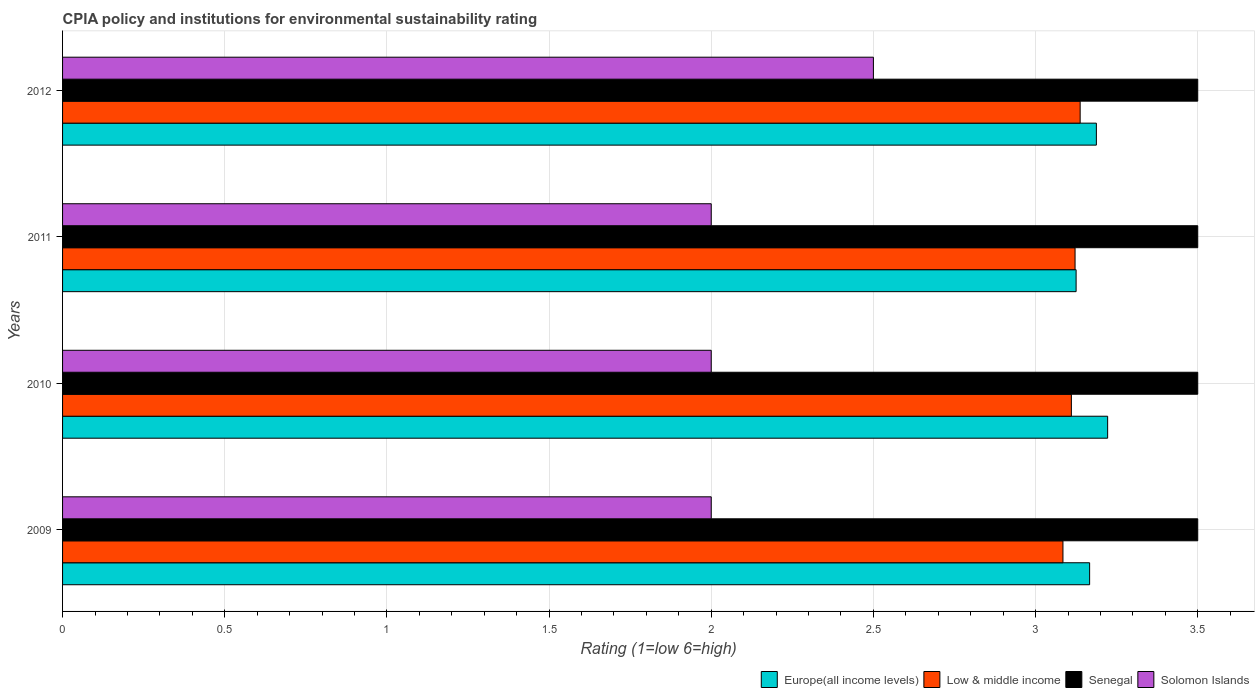Are the number of bars per tick equal to the number of legend labels?
Ensure brevity in your answer.  Yes. Are the number of bars on each tick of the Y-axis equal?
Your answer should be very brief. Yes. What is the label of the 4th group of bars from the top?
Offer a terse response. 2009. In how many cases, is the number of bars for a given year not equal to the number of legend labels?
Your answer should be compact. 0. What is the CPIA rating in Low & middle income in 2009?
Keep it short and to the point. 3.08. Across all years, what is the maximum CPIA rating in Low & middle income?
Offer a very short reply. 3.14. Across all years, what is the minimum CPIA rating in Low & middle income?
Provide a short and direct response. 3.08. What is the total CPIA rating in Low & middle income in the graph?
Provide a succinct answer. 12.45. What is the difference between the CPIA rating in Europe(all income levels) in 2009 and that in 2012?
Offer a terse response. -0.02. What is the difference between the CPIA rating in Senegal in 2011 and the CPIA rating in Low & middle income in 2012?
Make the answer very short. 0.36. What is the average CPIA rating in Europe(all income levels) per year?
Provide a succinct answer. 3.18. In how many years, is the CPIA rating in Senegal greater than 1.1 ?
Provide a succinct answer. 4. Is the CPIA rating in Europe(all income levels) in 2010 less than that in 2011?
Provide a short and direct response. No. What is the difference between the highest and the second highest CPIA rating in Europe(all income levels)?
Make the answer very short. 0.03. What is the difference between the highest and the lowest CPIA rating in Low & middle income?
Keep it short and to the point. 0.05. What does the 4th bar from the top in 2011 represents?
Your answer should be compact. Europe(all income levels). What does the 2nd bar from the bottom in 2011 represents?
Offer a terse response. Low & middle income. Are all the bars in the graph horizontal?
Provide a short and direct response. Yes. How many years are there in the graph?
Make the answer very short. 4. What is the difference between two consecutive major ticks on the X-axis?
Ensure brevity in your answer.  0.5. Are the values on the major ticks of X-axis written in scientific E-notation?
Your answer should be compact. No. Does the graph contain any zero values?
Provide a short and direct response. No. Does the graph contain grids?
Your answer should be compact. Yes. How are the legend labels stacked?
Offer a terse response. Horizontal. What is the title of the graph?
Make the answer very short. CPIA policy and institutions for environmental sustainability rating. What is the Rating (1=low 6=high) of Europe(all income levels) in 2009?
Make the answer very short. 3.17. What is the Rating (1=low 6=high) in Low & middle income in 2009?
Provide a succinct answer. 3.08. What is the Rating (1=low 6=high) in Senegal in 2009?
Keep it short and to the point. 3.5. What is the Rating (1=low 6=high) in Solomon Islands in 2009?
Your answer should be very brief. 2. What is the Rating (1=low 6=high) in Europe(all income levels) in 2010?
Offer a very short reply. 3.22. What is the Rating (1=low 6=high) of Low & middle income in 2010?
Ensure brevity in your answer.  3.11. What is the Rating (1=low 6=high) of Europe(all income levels) in 2011?
Offer a terse response. 3.12. What is the Rating (1=low 6=high) in Low & middle income in 2011?
Your answer should be very brief. 3.12. What is the Rating (1=low 6=high) of Senegal in 2011?
Your answer should be compact. 3.5. What is the Rating (1=low 6=high) in Solomon Islands in 2011?
Give a very brief answer. 2. What is the Rating (1=low 6=high) of Europe(all income levels) in 2012?
Provide a succinct answer. 3.19. What is the Rating (1=low 6=high) in Low & middle income in 2012?
Your response must be concise. 3.14. What is the Rating (1=low 6=high) of Solomon Islands in 2012?
Provide a succinct answer. 2.5. Across all years, what is the maximum Rating (1=low 6=high) in Europe(all income levels)?
Offer a very short reply. 3.22. Across all years, what is the maximum Rating (1=low 6=high) of Low & middle income?
Give a very brief answer. 3.14. Across all years, what is the maximum Rating (1=low 6=high) of Senegal?
Your response must be concise. 3.5. Across all years, what is the maximum Rating (1=low 6=high) in Solomon Islands?
Offer a terse response. 2.5. Across all years, what is the minimum Rating (1=low 6=high) in Europe(all income levels)?
Make the answer very short. 3.12. Across all years, what is the minimum Rating (1=low 6=high) of Low & middle income?
Give a very brief answer. 3.08. Across all years, what is the minimum Rating (1=low 6=high) of Solomon Islands?
Keep it short and to the point. 2. What is the total Rating (1=low 6=high) of Europe(all income levels) in the graph?
Provide a succinct answer. 12.7. What is the total Rating (1=low 6=high) of Low & middle income in the graph?
Make the answer very short. 12.45. What is the total Rating (1=low 6=high) of Solomon Islands in the graph?
Provide a short and direct response. 8.5. What is the difference between the Rating (1=low 6=high) in Europe(all income levels) in 2009 and that in 2010?
Provide a succinct answer. -0.06. What is the difference between the Rating (1=low 6=high) in Low & middle income in 2009 and that in 2010?
Your answer should be very brief. -0.03. What is the difference between the Rating (1=low 6=high) of Senegal in 2009 and that in 2010?
Keep it short and to the point. 0. What is the difference between the Rating (1=low 6=high) of Europe(all income levels) in 2009 and that in 2011?
Offer a terse response. 0.04. What is the difference between the Rating (1=low 6=high) of Low & middle income in 2009 and that in 2011?
Provide a succinct answer. -0.04. What is the difference between the Rating (1=low 6=high) of Europe(all income levels) in 2009 and that in 2012?
Keep it short and to the point. -0.02. What is the difference between the Rating (1=low 6=high) in Low & middle income in 2009 and that in 2012?
Keep it short and to the point. -0.05. What is the difference between the Rating (1=low 6=high) of Senegal in 2009 and that in 2012?
Provide a short and direct response. 0. What is the difference between the Rating (1=low 6=high) of Solomon Islands in 2009 and that in 2012?
Offer a terse response. -0.5. What is the difference between the Rating (1=low 6=high) in Europe(all income levels) in 2010 and that in 2011?
Give a very brief answer. 0.1. What is the difference between the Rating (1=low 6=high) of Low & middle income in 2010 and that in 2011?
Your answer should be compact. -0.01. What is the difference between the Rating (1=low 6=high) in Europe(all income levels) in 2010 and that in 2012?
Offer a very short reply. 0.03. What is the difference between the Rating (1=low 6=high) of Low & middle income in 2010 and that in 2012?
Offer a terse response. -0.03. What is the difference between the Rating (1=low 6=high) in Senegal in 2010 and that in 2012?
Provide a succinct answer. 0. What is the difference between the Rating (1=low 6=high) of Europe(all income levels) in 2011 and that in 2012?
Your response must be concise. -0.06. What is the difference between the Rating (1=low 6=high) in Low & middle income in 2011 and that in 2012?
Offer a very short reply. -0.02. What is the difference between the Rating (1=low 6=high) of Solomon Islands in 2011 and that in 2012?
Make the answer very short. -0.5. What is the difference between the Rating (1=low 6=high) in Europe(all income levels) in 2009 and the Rating (1=low 6=high) in Low & middle income in 2010?
Keep it short and to the point. 0.06. What is the difference between the Rating (1=low 6=high) in Europe(all income levels) in 2009 and the Rating (1=low 6=high) in Senegal in 2010?
Your answer should be very brief. -0.33. What is the difference between the Rating (1=low 6=high) in Low & middle income in 2009 and the Rating (1=low 6=high) in Senegal in 2010?
Your response must be concise. -0.42. What is the difference between the Rating (1=low 6=high) in Low & middle income in 2009 and the Rating (1=low 6=high) in Solomon Islands in 2010?
Offer a terse response. 1.08. What is the difference between the Rating (1=low 6=high) in Senegal in 2009 and the Rating (1=low 6=high) in Solomon Islands in 2010?
Provide a short and direct response. 1.5. What is the difference between the Rating (1=low 6=high) in Europe(all income levels) in 2009 and the Rating (1=low 6=high) in Low & middle income in 2011?
Your answer should be compact. 0.04. What is the difference between the Rating (1=low 6=high) in Europe(all income levels) in 2009 and the Rating (1=low 6=high) in Solomon Islands in 2011?
Your response must be concise. 1.17. What is the difference between the Rating (1=low 6=high) of Low & middle income in 2009 and the Rating (1=low 6=high) of Senegal in 2011?
Make the answer very short. -0.42. What is the difference between the Rating (1=low 6=high) of Low & middle income in 2009 and the Rating (1=low 6=high) of Solomon Islands in 2011?
Your response must be concise. 1.08. What is the difference between the Rating (1=low 6=high) of Europe(all income levels) in 2009 and the Rating (1=low 6=high) of Low & middle income in 2012?
Keep it short and to the point. 0.03. What is the difference between the Rating (1=low 6=high) in Low & middle income in 2009 and the Rating (1=low 6=high) in Senegal in 2012?
Your answer should be very brief. -0.42. What is the difference between the Rating (1=low 6=high) of Low & middle income in 2009 and the Rating (1=low 6=high) of Solomon Islands in 2012?
Provide a short and direct response. 0.58. What is the difference between the Rating (1=low 6=high) in Senegal in 2009 and the Rating (1=low 6=high) in Solomon Islands in 2012?
Make the answer very short. 1. What is the difference between the Rating (1=low 6=high) in Europe(all income levels) in 2010 and the Rating (1=low 6=high) in Low & middle income in 2011?
Ensure brevity in your answer.  0.1. What is the difference between the Rating (1=low 6=high) of Europe(all income levels) in 2010 and the Rating (1=low 6=high) of Senegal in 2011?
Your answer should be compact. -0.28. What is the difference between the Rating (1=low 6=high) of Europe(all income levels) in 2010 and the Rating (1=low 6=high) of Solomon Islands in 2011?
Give a very brief answer. 1.22. What is the difference between the Rating (1=low 6=high) in Low & middle income in 2010 and the Rating (1=low 6=high) in Senegal in 2011?
Offer a terse response. -0.39. What is the difference between the Rating (1=low 6=high) in Low & middle income in 2010 and the Rating (1=low 6=high) in Solomon Islands in 2011?
Ensure brevity in your answer.  1.11. What is the difference between the Rating (1=low 6=high) in Europe(all income levels) in 2010 and the Rating (1=low 6=high) in Low & middle income in 2012?
Provide a short and direct response. 0.08. What is the difference between the Rating (1=low 6=high) of Europe(all income levels) in 2010 and the Rating (1=low 6=high) of Senegal in 2012?
Your answer should be very brief. -0.28. What is the difference between the Rating (1=low 6=high) in Europe(all income levels) in 2010 and the Rating (1=low 6=high) in Solomon Islands in 2012?
Your answer should be compact. 0.72. What is the difference between the Rating (1=low 6=high) of Low & middle income in 2010 and the Rating (1=low 6=high) of Senegal in 2012?
Provide a short and direct response. -0.39. What is the difference between the Rating (1=low 6=high) in Low & middle income in 2010 and the Rating (1=low 6=high) in Solomon Islands in 2012?
Keep it short and to the point. 0.61. What is the difference between the Rating (1=low 6=high) in Senegal in 2010 and the Rating (1=low 6=high) in Solomon Islands in 2012?
Ensure brevity in your answer.  1. What is the difference between the Rating (1=low 6=high) in Europe(all income levels) in 2011 and the Rating (1=low 6=high) in Low & middle income in 2012?
Provide a succinct answer. -0.01. What is the difference between the Rating (1=low 6=high) in Europe(all income levels) in 2011 and the Rating (1=low 6=high) in Senegal in 2012?
Your response must be concise. -0.38. What is the difference between the Rating (1=low 6=high) of Europe(all income levels) in 2011 and the Rating (1=low 6=high) of Solomon Islands in 2012?
Your answer should be very brief. 0.62. What is the difference between the Rating (1=low 6=high) of Low & middle income in 2011 and the Rating (1=low 6=high) of Senegal in 2012?
Your answer should be compact. -0.38. What is the difference between the Rating (1=low 6=high) in Low & middle income in 2011 and the Rating (1=low 6=high) in Solomon Islands in 2012?
Offer a very short reply. 0.62. What is the average Rating (1=low 6=high) in Europe(all income levels) per year?
Offer a very short reply. 3.18. What is the average Rating (1=low 6=high) in Low & middle income per year?
Give a very brief answer. 3.11. What is the average Rating (1=low 6=high) of Senegal per year?
Ensure brevity in your answer.  3.5. What is the average Rating (1=low 6=high) of Solomon Islands per year?
Make the answer very short. 2.12. In the year 2009, what is the difference between the Rating (1=low 6=high) of Europe(all income levels) and Rating (1=low 6=high) of Low & middle income?
Offer a terse response. 0.08. In the year 2009, what is the difference between the Rating (1=low 6=high) of Low & middle income and Rating (1=low 6=high) of Senegal?
Provide a succinct answer. -0.42. In the year 2009, what is the difference between the Rating (1=low 6=high) of Low & middle income and Rating (1=low 6=high) of Solomon Islands?
Your answer should be compact. 1.08. In the year 2010, what is the difference between the Rating (1=low 6=high) in Europe(all income levels) and Rating (1=low 6=high) in Low & middle income?
Offer a terse response. 0.11. In the year 2010, what is the difference between the Rating (1=low 6=high) of Europe(all income levels) and Rating (1=low 6=high) of Senegal?
Provide a succinct answer. -0.28. In the year 2010, what is the difference between the Rating (1=low 6=high) in Europe(all income levels) and Rating (1=low 6=high) in Solomon Islands?
Make the answer very short. 1.22. In the year 2010, what is the difference between the Rating (1=low 6=high) in Low & middle income and Rating (1=low 6=high) in Senegal?
Your answer should be compact. -0.39. In the year 2010, what is the difference between the Rating (1=low 6=high) in Low & middle income and Rating (1=low 6=high) in Solomon Islands?
Your answer should be very brief. 1.11. In the year 2010, what is the difference between the Rating (1=low 6=high) of Senegal and Rating (1=low 6=high) of Solomon Islands?
Offer a very short reply. 1.5. In the year 2011, what is the difference between the Rating (1=low 6=high) in Europe(all income levels) and Rating (1=low 6=high) in Low & middle income?
Make the answer very short. 0. In the year 2011, what is the difference between the Rating (1=low 6=high) of Europe(all income levels) and Rating (1=low 6=high) of Senegal?
Your answer should be compact. -0.38. In the year 2011, what is the difference between the Rating (1=low 6=high) of Europe(all income levels) and Rating (1=low 6=high) of Solomon Islands?
Offer a terse response. 1.12. In the year 2011, what is the difference between the Rating (1=low 6=high) of Low & middle income and Rating (1=low 6=high) of Senegal?
Your answer should be very brief. -0.38. In the year 2011, what is the difference between the Rating (1=low 6=high) of Low & middle income and Rating (1=low 6=high) of Solomon Islands?
Your response must be concise. 1.12. In the year 2012, what is the difference between the Rating (1=low 6=high) in Europe(all income levels) and Rating (1=low 6=high) in Senegal?
Offer a very short reply. -0.31. In the year 2012, what is the difference between the Rating (1=low 6=high) in Europe(all income levels) and Rating (1=low 6=high) in Solomon Islands?
Provide a short and direct response. 0.69. In the year 2012, what is the difference between the Rating (1=low 6=high) of Low & middle income and Rating (1=low 6=high) of Senegal?
Offer a terse response. -0.36. In the year 2012, what is the difference between the Rating (1=low 6=high) of Low & middle income and Rating (1=low 6=high) of Solomon Islands?
Your answer should be compact. 0.64. In the year 2012, what is the difference between the Rating (1=low 6=high) in Senegal and Rating (1=low 6=high) in Solomon Islands?
Offer a terse response. 1. What is the ratio of the Rating (1=low 6=high) in Europe(all income levels) in 2009 to that in 2010?
Give a very brief answer. 0.98. What is the ratio of the Rating (1=low 6=high) in Solomon Islands in 2009 to that in 2010?
Provide a succinct answer. 1. What is the ratio of the Rating (1=low 6=high) in Europe(all income levels) in 2009 to that in 2011?
Offer a terse response. 1.01. What is the ratio of the Rating (1=low 6=high) of Senegal in 2009 to that in 2011?
Provide a short and direct response. 1. What is the ratio of the Rating (1=low 6=high) of Low & middle income in 2009 to that in 2012?
Your answer should be very brief. 0.98. What is the ratio of the Rating (1=low 6=high) of Solomon Islands in 2009 to that in 2012?
Make the answer very short. 0.8. What is the ratio of the Rating (1=low 6=high) of Europe(all income levels) in 2010 to that in 2011?
Offer a terse response. 1.03. What is the ratio of the Rating (1=low 6=high) of Senegal in 2010 to that in 2011?
Ensure brevity in your answer.  1. What is the ratio of the Rating (1=low 6=high) of Solomon Islands in 2010 to that in 2011?
Provide a short and direct response. 1. What is the ratio of the Rating (1=low 6=high) of Europe(all income levels) in 2010 to that in 2012?
Your answer should be compact. 1.01. What is the ratio of the Rating (1=low 6=high) in Senegal in 2010 to that in 2012?
Make the answer very short. 1. What is the ratio of the Rating (1=low 6=high) in Solomon Islands in 2010 to that in 2012?
Offer a terse response. 0.8. What is the ratio of the Rating (1=low 6=high) in Europe(all income levels) in 2011 to that in 2012?
Offer a very short reply. 0.98. What is the ratio of the Rating (1=low 6=high) in Low & middle income in 2011 to that in 2012?
Offer a very short reply. 0.99. What is the ratio of the Rating (1=low 6=high) in Senegal in 2011 to that in 2012?
Give a very brief answer. 1. What is the ratio of the Rating (1=low 6=high) of Solomon Islands in 2011 to that in 2012?
Your response must be concise. 0.8. What is the difference between the highest and the second highest Rating (1=low 6=high) of Europe(all income levels)?
Provide a short and direct response. 0.03. What is the difference between the highest and the second highest Rating (1=low 6=high) of Low & middle income?
Ensure brevity in your answer.  0.02. What is the difference between the highest and the second highest Rating (1=low 6=high) in Senegal?
Offer a terse response. 0. What is the difference between the highest and the second highest Rating (1=low 6=high) in Solomon Islands?
Your response must be concise. 0.5. What is the difference between the highest and the lowest Rating (1=low 6=high) in Europe(all income levels)?
Provide a short and direct response. 0.1. What is the difference between the highest and the lowest Rating (1=low 6=high) of Low & middle income?
Your answer should be very brief. 0.05. What is the difference between the highest and the lowest Rating (1=low 6=high) of Senegal?
Ensure brevity in your answer.  0. What is the difference between the highest and the lowest Rating (1=low 6=high) in Solomon Islands?
Keep it short and to the point. 0.5. 